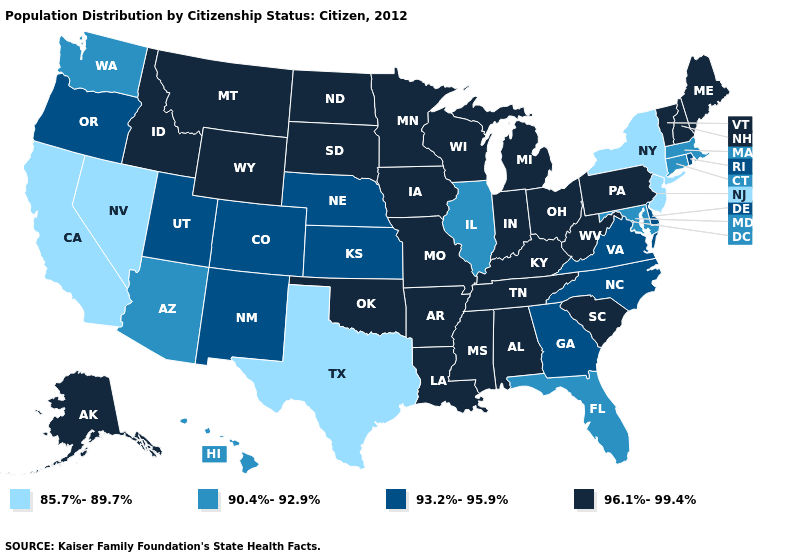Is the legend a continuous bar?
Quick response, please. No. Which states have the lowest value in the West?
Answer briefly. California, Nevada. What is the lowest value in the West?
Write a very short answer. 85.7%-89.7%. Is the legend a continuous bar?
Keep it brief. No. What is the lowest value in the Northeast?
Give a very brief answer. 85.7%-89.7%. Among the states that border Louisiana , which have the highest value?
Short answer required. Arkansas, Mississippi. Does the map have missing data?
Write a very short answer. No. Which states hav the highest value in the South?
Short answer required. Alabama, Arkansas, Kentucky, Louisiana, Mississippi, Oklahoma, South Carolina, Tennessee, West Virginia. Does New York have the lowest value in the Northeast?
Write a very short answer. Yes. Name the states that have a value in the range 93.2%-95.9%?
Keep it brief. Colorado, Delaware, Georgia, Kansas, Nebraska, New Mexico, North Carolina, Oregon, Rhode Island, Utah, Virginia. Name the states that have a value in the range 85.7%-89.7%?
Quick response, please. California, Nevada, New Jersey, New York, Texas. Name the states that have a value in the range 90.4%-92.9%?
Be succinct. Arizona, Connecticut, Florida, Hawaii, Illinois, Maryland, Massachusetts, Washington. What is the value of Florida?
Concise answer only. 90.4%-92.9%. What is the value of Nebraska?
Answer briefly. 93.2%-95.9%. Among the states that border Florida , does Georgia have the highest value?
Quick response, please. No. 